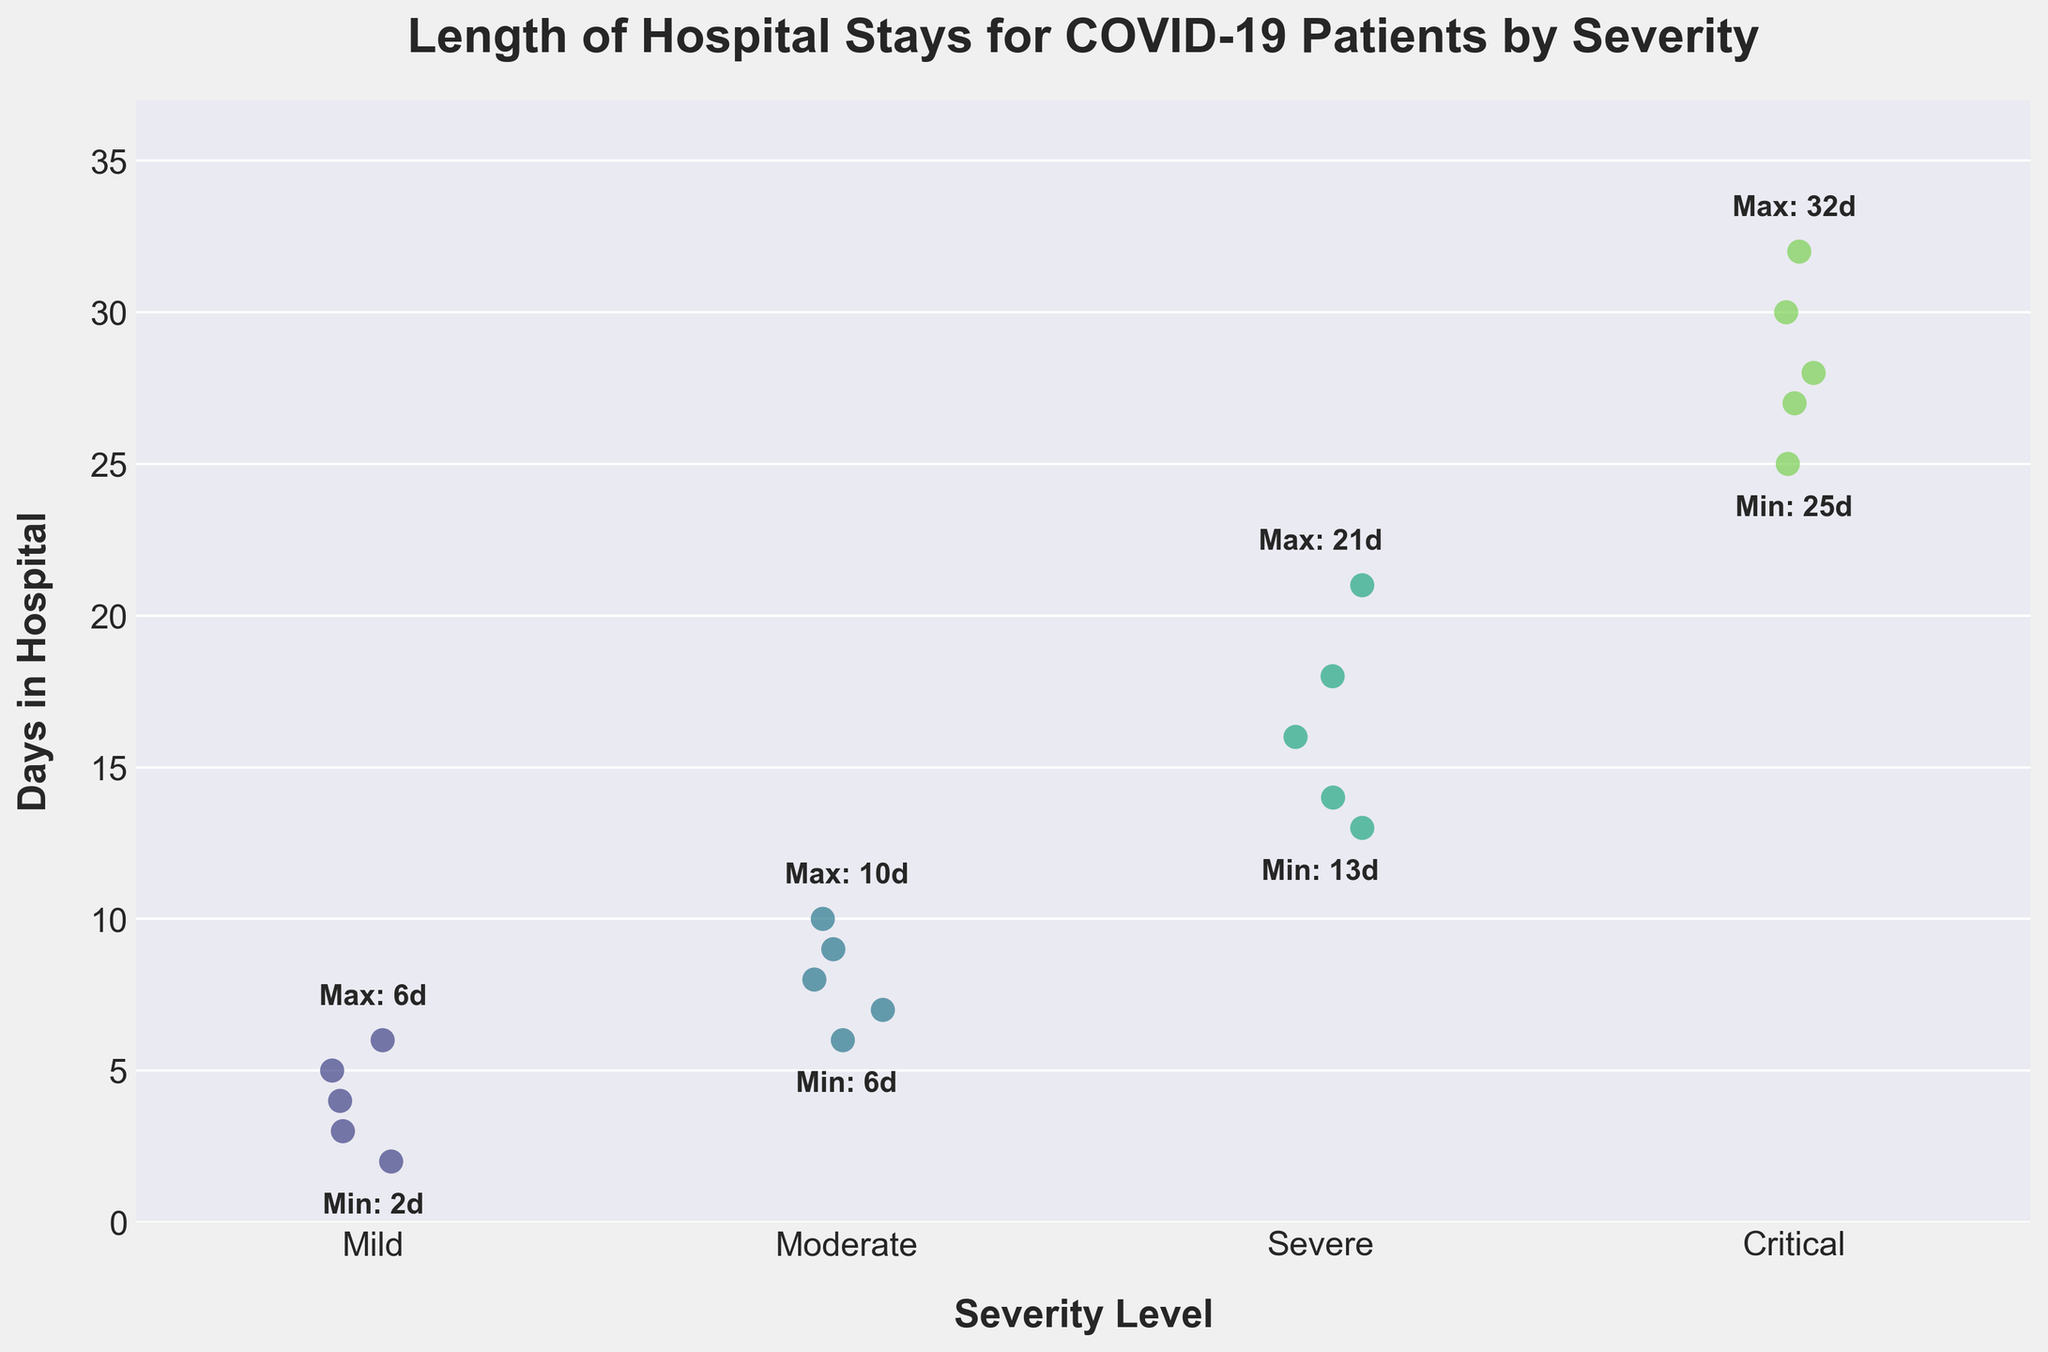What's the title of the figure? The title is displayed prominently at the top of the figure and provides a summary of what the strip plot represents.
Answer: Length of Hospital Stays for COVID-19 Patients by Severity What is the range of hospital stays for Mild cases? By observing the Mild category on the x-axis, the vertical spread of dots shows the range. The minimum and maximum indicators provide specific values.
Answer: 2 to 6 days Which severity level has the longest observed hospital stay? Look at the top of the plot to see which category has the highest dot. The maximum indicator text confirms this.
Answer: Critical How many days did the shortest Severe case stay in the hospital? Locate the Severe category on the x-axis and find the lowest dot. The minimum indicator text confirms this value.
Answer: 13 days Compare the average length of stay between Moderate and Critical cases. First, identify the points for both categories. Then, calculate the average for Moderate (7, 9, 8, 10, 6: sum=40, avg=8) and Critical (25, 30, 28, 32, 27: sum=142, avg=28.4).
Answer: Moderate: 8 days, Critical: 28.4 days Which group has the smallest range of hospital stays? Observe the vertical spread of dots for each category and compare. The Mild group shows the smallest spread from 2 to 6 days.
Answer: Mild Between Severe and Critical cases, which has a higher minimum length of stay? Locate the minimum values indicated on the plot for both Severe and Critical categories.
Answer: Critical How does the spread of Moderate cases compare to Mild cases? Compare the vertical dispersion of points between Moderate and Mild. Moderate spans from 6 to 10 days, while Mild spans from 2 to 6 days.
Answer: Moderate has a wider spread What is the maximum number of days a patient stayed in the hospital for a Severe case? Observe the Severe category for the top-most dot. The maximum indicator text confirms this.
Answer: 21 days What is the overall trend in hospital stay duration as severity increases? Observe the strip plot from Mild to Critical. There is a clear upward trend, with higher severity levels showing longer stays.
Answer: Duration increases with severity 